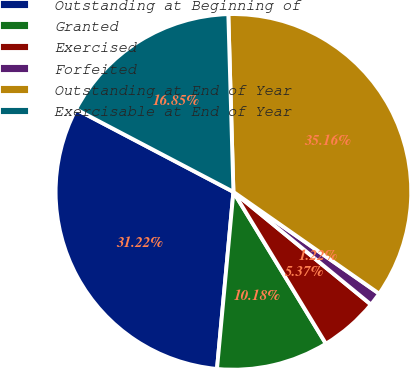Convert chart. <chart><loc_0><loc_0><loc_500><loc_500><pie_chart><fcel>Outstanding at Beginning of<fcel>Granted<fcel>Exercised<fcel>Forfeited<fcel>Outstanding at End of Year<fcel>Exercisable at End of Year<nl><fcel>31.22%<fcel>10.18%<fcel>5.37%<fcel>1.22%<fcel>35.16%<fcel>16.85%<nl></chart> 